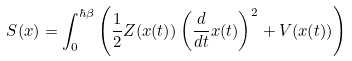<formula> <loc_0><loc_0><loc_500><loc_500>S ( x ) = \int _ { 0 } ^ { \hbar { \beta } } \left ( { \frac { 1 } { 2 } } Z ( x ( t ) ) \left ( { \frac { d } { d t } } x ( t ) \right ) ^ { 2 } + V ( x ( t ) ) \right )</formula> 